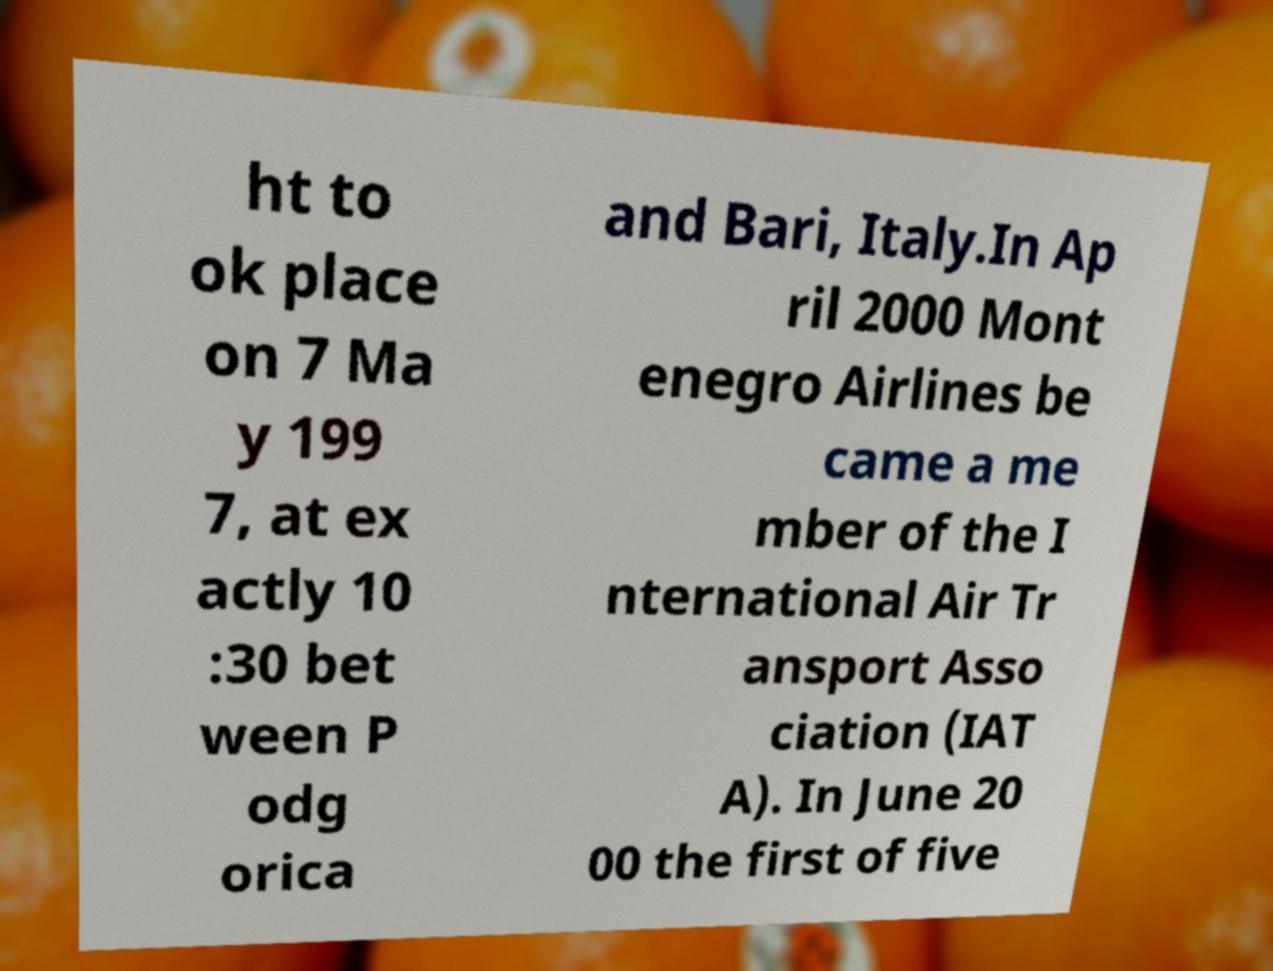I need the written content from this picture converted into text. Can you do that? ht to ok place on 7 Ma y 199 7, at ex actly 10 :30 bet ween P odg orica and Bari, Italy.In Ap ril 2000 Mont enegro Airlines be came a me mber of the I nternational Air Tr ansport Asso ciation (IAT A). In June 20 00 the first of five 